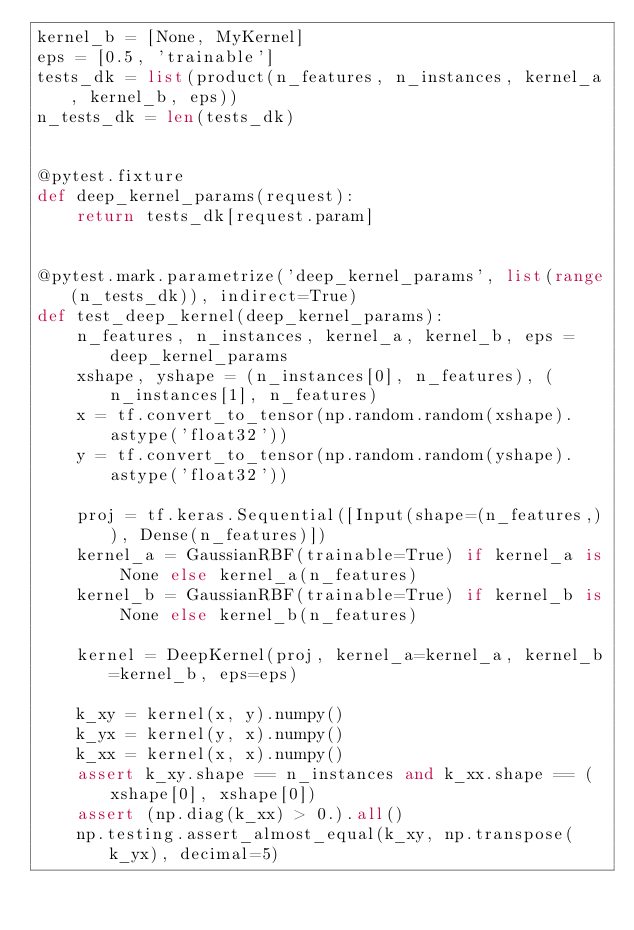<code> <loc_0><loc_0><loc_500><loc_500><_Python_>kernel_b = [None, MyKernel]
eps = [0.5, 'trainable']
tests_dk = list(product(n_features, n_instances, kernel_a, kernel_b, eps))
n_tests_dk = len(tests_dk)


@pytest.fixture
def deep_kernel_params(request):
    return tests_dk[request.param]


@pytest.mark.parametrize('deep_kernel_params', list(range(n_tests_dk)), indirect=True)
def test_deep_kernel(deep_kernel_params):
    n_features, n_instances, kernel_a, kernel_b, eps = deep_kernel_params
    xshape, yshape = (n_instances[0], n_features), (n_instances[1], n_features)
    x = tf.convert_to_tensor(np.random.random(xshape).astype('float32'))
    y = tf.convert_to_tensor(np.random.random(yshape).astype('float32'))

    proj = tf.keras.Sequential([Input(shape=(n_features,)), Dense(n_features)])
    kernel_a = GaussianRBF(trainable=True) if kernel_a is None else kernel_a(n_features)
    kernel_b = GaussianRBF(trainable=True) if kernel_b is None else kernel_b(n_features)

    kernel = DeepKernel(proj, kernel_a=kernel_a, kernel_b=kernel_b, eps=eps)

    k_xy = kernel(x, y).numpy()
    k_yx = kernel(y, x).numpy()
    k_xx = kernel(x, x).numpy()
    assert k_xy.shape == n_instances and k_xx.shape == (xshape[0], xshape[0])
    assert (np.diag(k_xx) > 0.).all()
    np.testing.assert_almost_equal(k_xy, np.transpose(k_yx), decimal=5)
</code> 